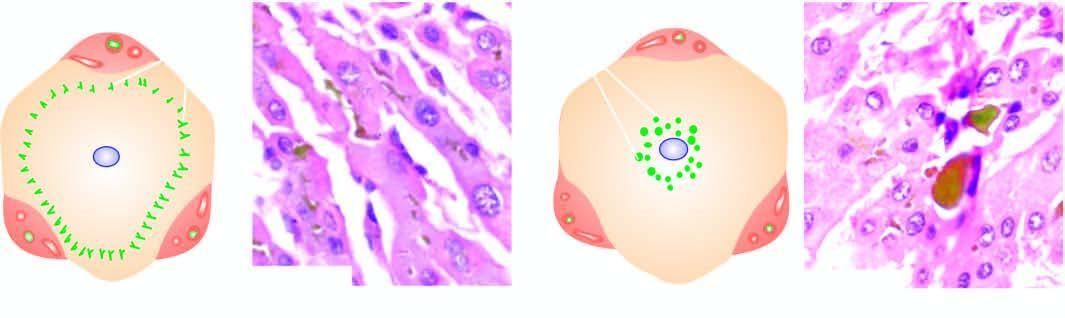s an asbestos body characterised by elongated bile plugs in the canaliculi of hepatocytes at the periphery of the lobule?
Answer the question using a single word or phrase. No 